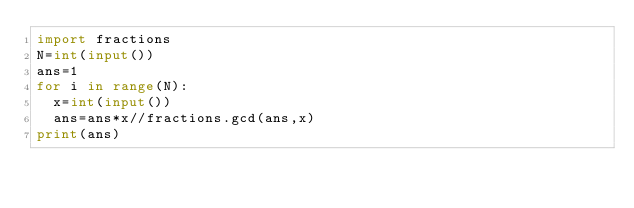<code> <loc_0><loc_0><loc_500><loc_500><_Python_>import fractions
N=int(input())
ans=1
for i in range(N):
	x=int(input())
	ans=ans*x//fractions.gcd(ans,x)
print(ans)</code> 